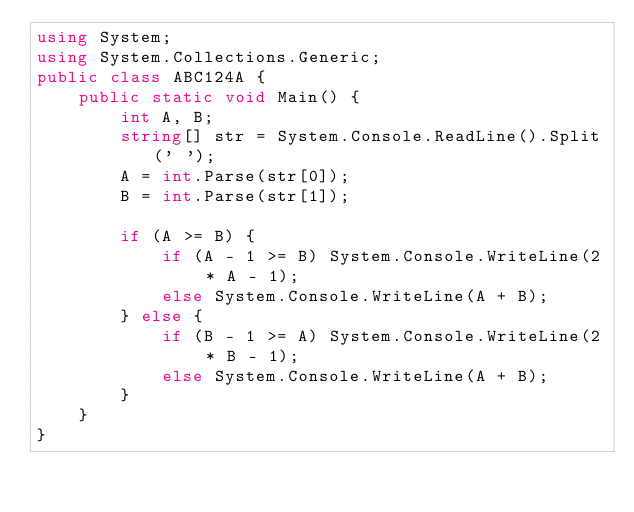Convert code to text. <code><loc_0><loc_0><loc_500><loc_500><_C#_>using System;
using System.Collections.Generic;
public class ABC124A {
    public static void Main() {
        int A, B;
        string[] str = System.Console.ReadLine().Split(' ');
        A = int.Parse(str[0]);
        B = int.Parse(str[1]);

        if (A >= B) {
            if (A - 1 >= B) System.Console.WriteLine(2 * A - 1);
            else System.Console.WriteLine(A + B);
        } else {
            if (B - 1 >= A) System.Console.WriteLine(2 * B - 1);
            else System.Console.WriteLine(A + B);
        }
    }
}</code> 